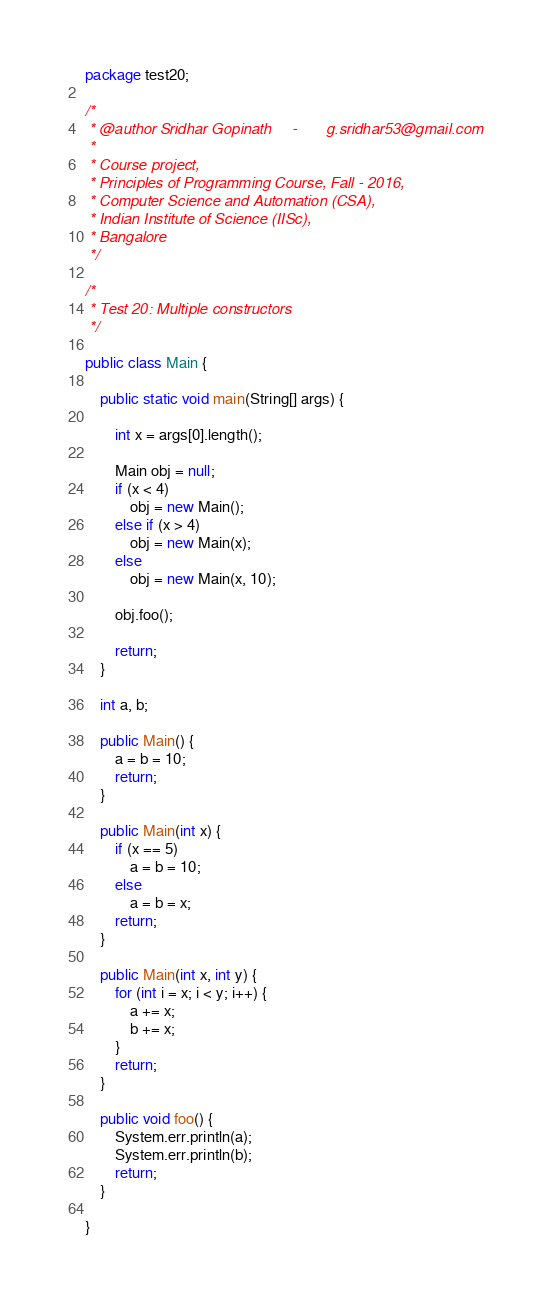Convert code to text. <code><loc_0><loc_0><loc_500><loc_500><_Java_>package test20;

/*
 * @author Sridhar Gopinath		-		g.sridhar53@gmail.com
 * 
 * Course project,
 * Principles of Programming Course, Fall - 2016,
 * Computer Science and Automation (CSA),
 * Indian Institute of Science (IISc),
 * Bangalore
 */

/*
 * Test 20: Multiple constructors
 */

public class Main {

	public static void main(String[] args) {

		int x = args[0].length();

		Main obj = null;
		if (x < 4)
			obj = new Main();
		else if (x > 4)
			obj = new Main(x);
		else
			obj = new Main(x, 10);

		obj.foo();

		return;
	}

	int a, b;

	public Main() {
		a = b = 10;
		return;
	}

	public Main(int x) {
		if (x == 5)
			a = b = 10;
		else
			a = b = x;
		return;
	}

	public Main(int x, int y) {
		for (int i = x; i < y; i++) {
			a += x;
			b += x;
		}
		return;
	}

	public void foo() {
		System.err.println(a);
		System.err.println(b);
		return;
	}

}</code> 